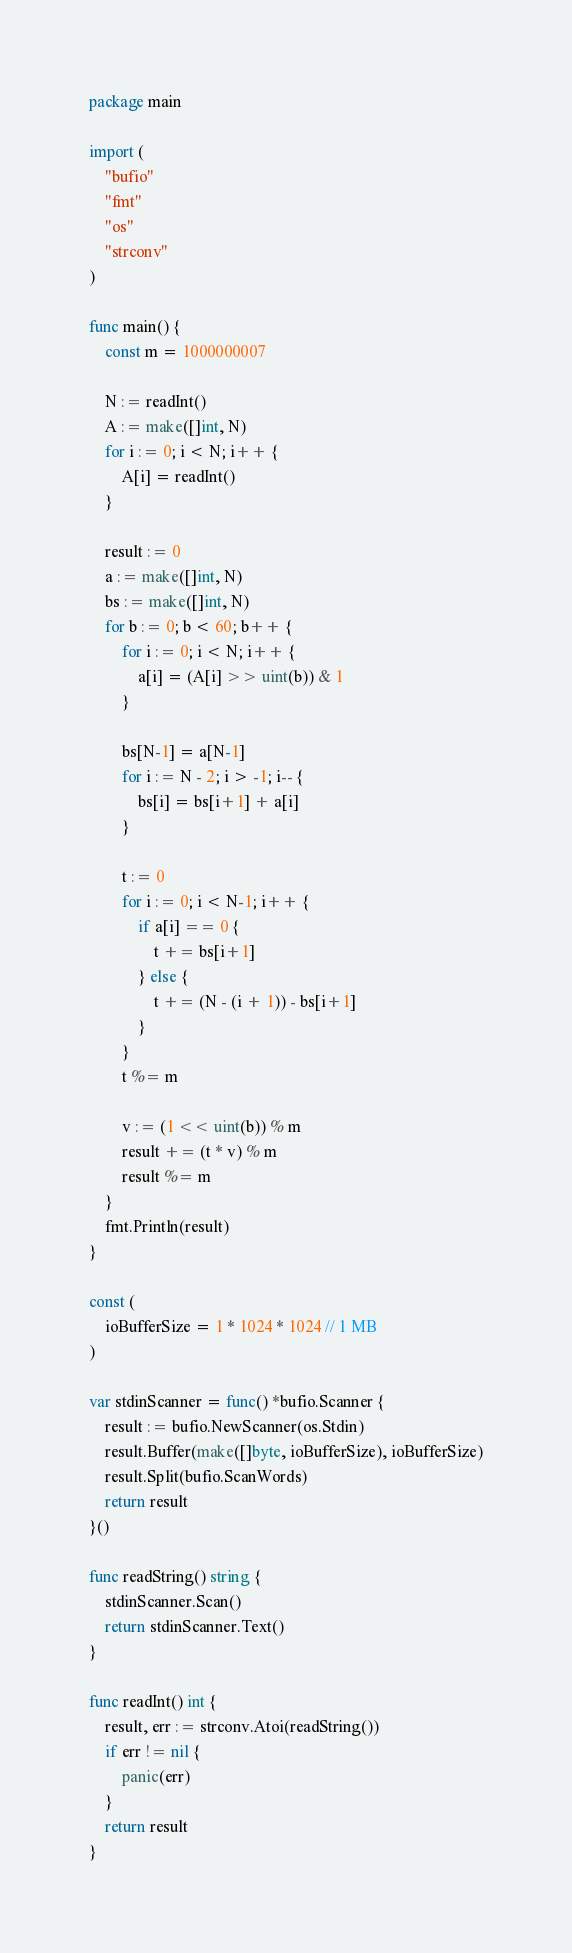Convert code to text. <code><loc_0><loc_0><loc_500><loc_500><_Go_>package main

import (
	"bufio"
	"fmt"
	"os"
	"strconv"
)

func main() {
	const m = 1000000007

	N := readInt()
	A := make([]int, N)
	for i := 0; i < N; i++ {
		A[i] = readInt()
	}

	result := 0
	a := make([]int, N)
	bs := make([]int, N)
	for b := 0; b < 60; b++ {
		for i := 0; i < N; i++ {
			a[i] = (A[i] >> uint(b)) & 1
		}

		bs[N-1] = a[N-1]
		for i := N - 2; i > -1; i-- {
			bs[i] = bs[i+1] + a[i]
		}

		t := 0
		for i := 0; i < N-1; i++ {
			if a[i] == 0 {
				t += bs[i+1]
			} else {
				t += (N - (i + 1)) - bs[i+1]
			}
		}
		t %= m

		v := (1 << uint(b)) % m
		result += (t * v) % m
		result %= m
	}
	fmt.Println(result)
}

const (
	ioBufferSize = 1 * 1024 * 1024 // 1 MB
)

var stdinScanner = func() *bufio.Scanner {
	result := bufio.NewScanner(os.Stdin)
	result.Buffer(make([]byte, ioBufferSize), ioBufferSize)
	result.Split(bufio.ScanWords)
	return result
}()

func readString() string {
	stdinScanner.Scan()
	return stdinScanner.Text()
}

func readInt() int {
	result, err := strconv.Atoi(readString())
	if err != nil {
		panic(err)
	}
	return result
}
</code> 